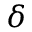Convert formula to latex. <formula><loc_0><loc_0><loc_500><loc_500>\delta</formula> 